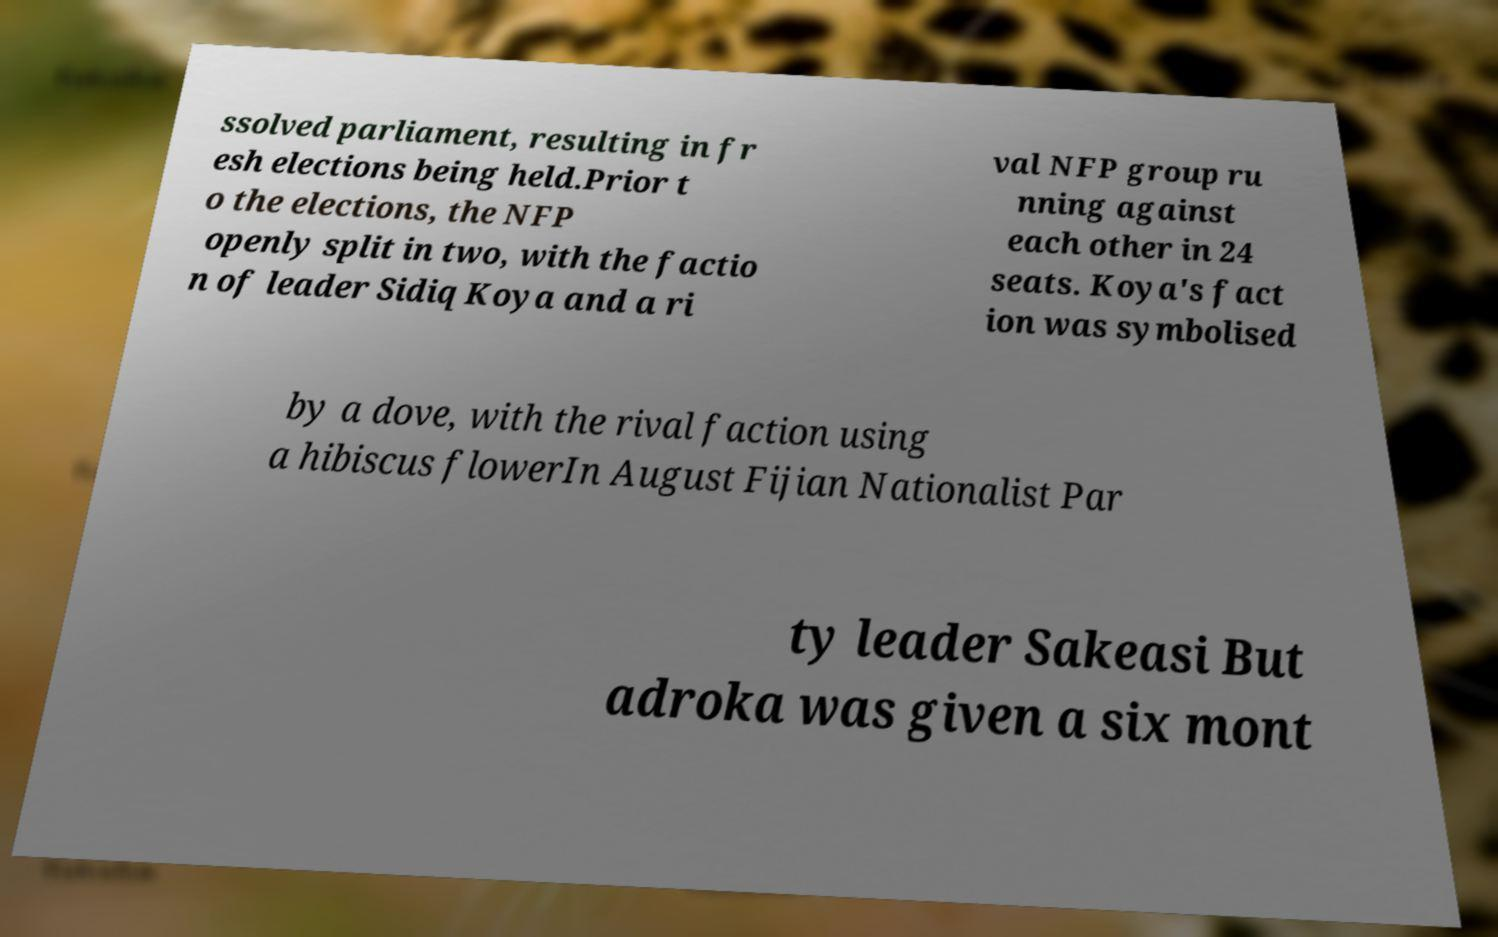Could you assist in decoding the text presented in this image and type it out clearly? ssolved parliament, resulting in fr esh elections being held.Prior t o the elections, the NFP openly split in two, with the factio n of leader Sidiq Koya and a ri val NFP group ru nning against each other in 24 seats. Koya's fact ion was symbolised by a dove, with the rival faction using a hibiscus flowerIn August Fijian Nationalist Par ty leader Sakeasi But adroka was given a six mont 